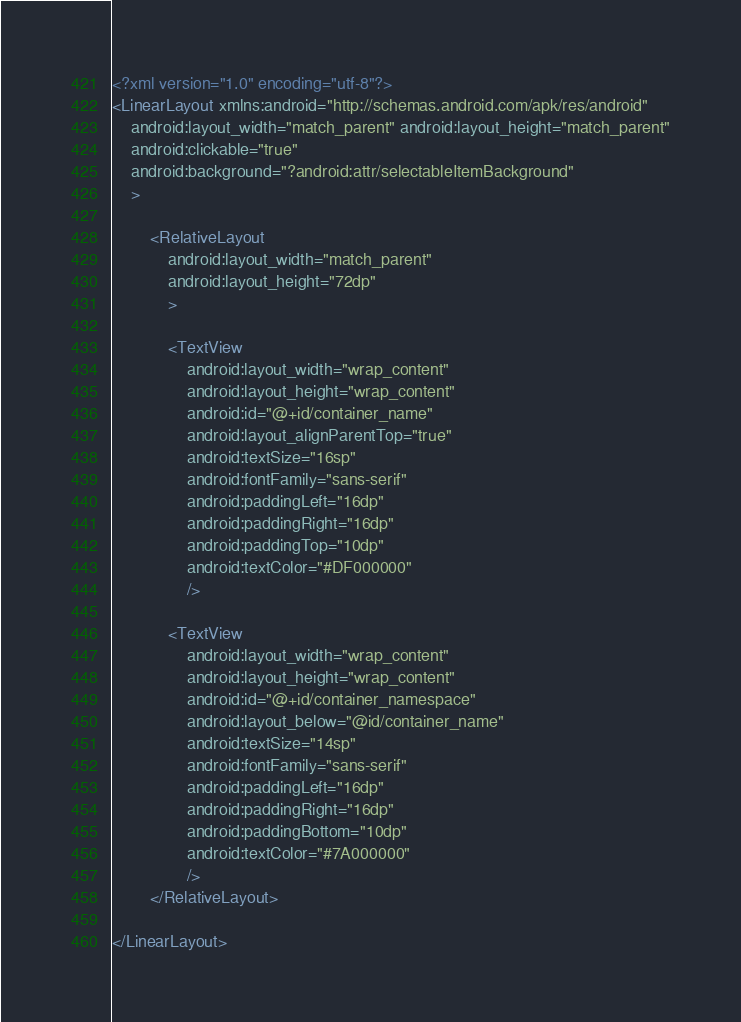<code> <loc_0><loc_0><loc_500><loc_500><_XML_><?xml version="1.0" encoding="utf-8"?>
<LinearLayout xmlns:android="http://schemas.android.com/apk/res/android"
    android:layout_width="match_parent" android:layout_height="match_parent"
    android:clickable="true"
    android:background="?android:attr/selectableItemBackground"
    >

        <RelativeLayout
            android:layout_width="match_parent"
            android:layout_height="72dp"
            >

            <TextView
                android:layout_width="wrap_content"
                android:layout_height="wrap_content"
                android:id="@+id/container_name"
                android:layout_alignParentTop="true"
                android:textSize="16sp"
                android:fontFamily="sans-serif"
                android:paddingLeft="16dp"
                android:paddingRight="16dp"
                android:paddingTop="10dp"
                android:textColor="#DF000000"
                />

            <TextView
                android:layout_width="wrap_content"
                android:layout_height="wrap_content"
                android:id="@+id/container_namespace"
                android:layout_below="@id/container_name"
                android:textSize="14sp"
                android:fontFamily="sans-serif"
                android:paddingLeft="16dp"
                android:paddingRight="16dp"
                android:paddingBottom="10dp"
                android:textColor="#7A000000"
                />
        </RelativeLayout>

</LinearLayout></code> 